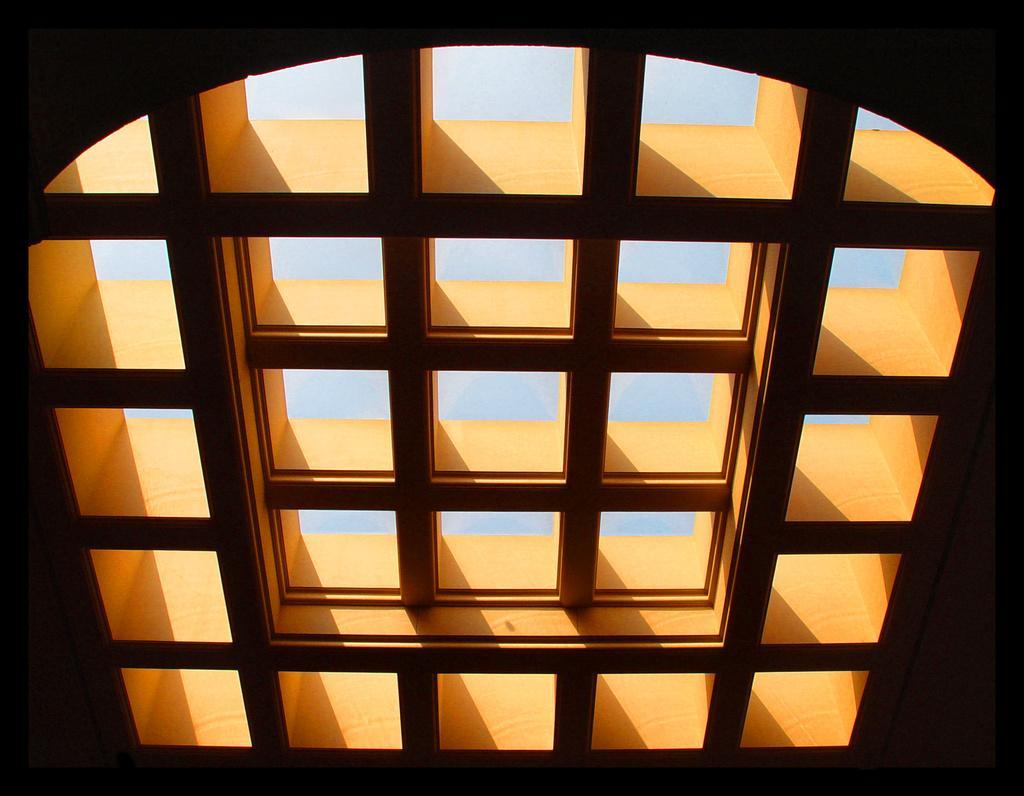How would you summarize this image in a sentence or two? In this picture I can see the roof. 